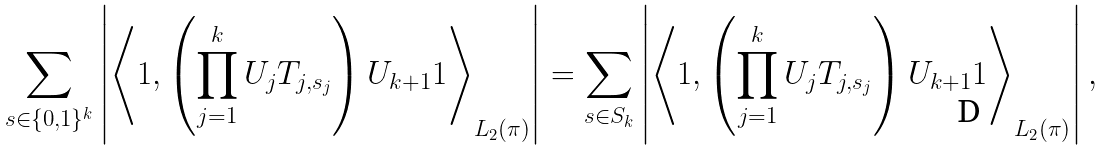Convert formula to latex. <formula><loc_0><loc_0><loc_500><loc_500>\sum _ { s \in \{ 0 , 1 \} ^ { k } } \left | \left \langle 1 , \left ( \prod _ { j = 1 } ^ { k } U _ { j } T _ { j , s _ { j } } \right ) U _ { k + 1 } 1 \right \rangle _ { L _ { 2 } ( \pi ) } \right | = \sum _ { s \in S _ { k } } \left | \left \langle 1 , \left ( \prod _ { j = 1 } ^ { k } U _ { j } T _ { j , s _ { j } } \right ) U _ { k + 1 } 1 \right \rangle _ { L _ { 2 } ( \pi ) } \right | ,</formula> 